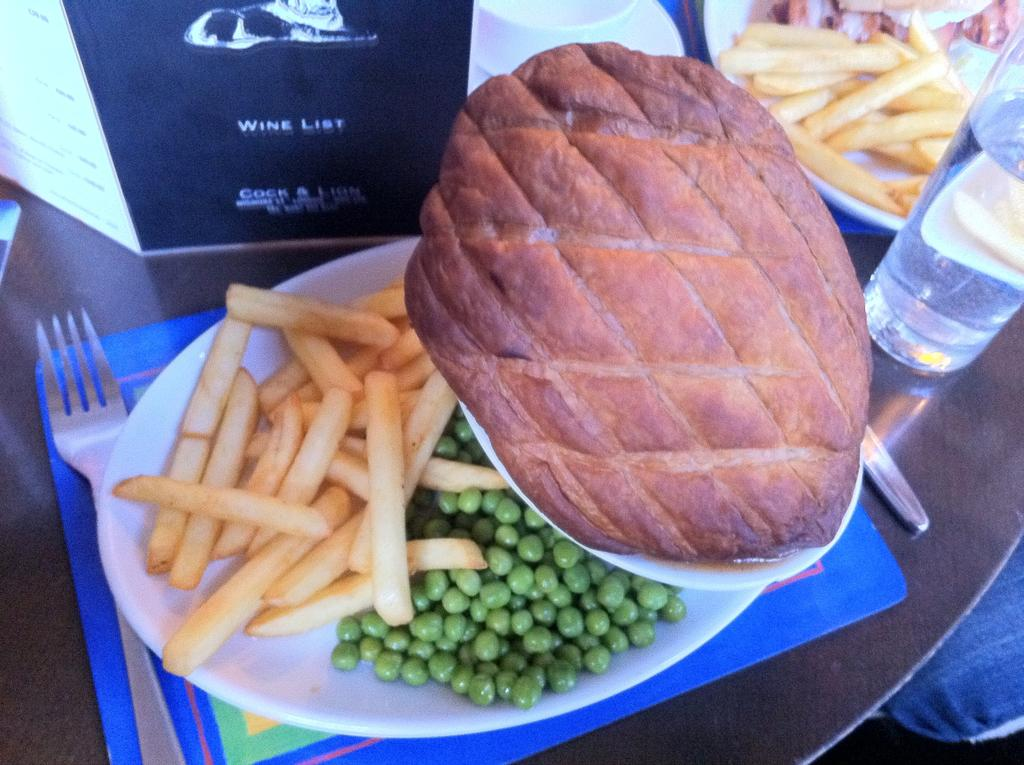What utensil can be seen in the image? There is a fork in the image. What type of container is present for holding a liquid? There is a bottle in the image. What type of container is present for holding a hot beverage? There is a cup in the image. What type of dish is present for holding a saucer or small plate? There is a saucer in the image. What type of item provides information about available food items? There is a menu card in the image. What type of food item can be seen on a plate in the image? There is a plate with fries in the image. What type of food items are present on the plate? There are food items on the plate. Where are all these objects placed? All these objects are placed on a table. Reasoning: Let's think step by identifying the main subjects and objects in the image based on the provided facts. We then formulate questions that focus on the location and characteristics of these subjects and objects, ensuring that each question can be answered definitively with the information given. We avoid yes/no questions and ensure that the language is simple and clear. Absurd Question/Answer: What type of guide is present in the image to help people navigate through the area? There is no guide present in the image; it only contains a fork, bottle, cup, saucer, menu card, plate with fries, and food items on the plate, all placed on a table. What type of rod is present in the image to help people catch fish? There is no rod present in the image; it only contains a fork, bottle, cup, saucer, menu card, plate with fries, and food items on the plate, all placed on a table. 